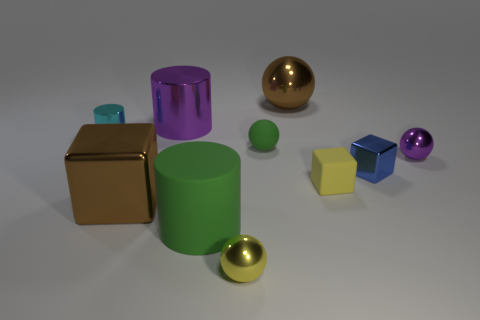How many objects are there in total? Including all visible items, there are a total of nine objects in the image. 